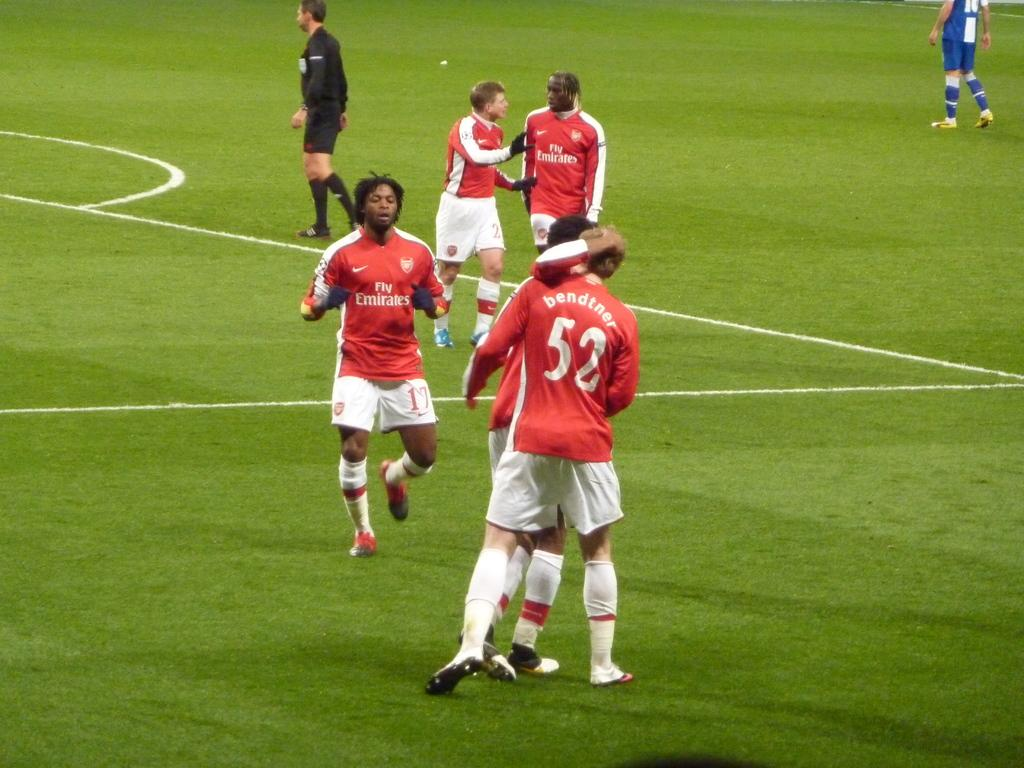Provide a one-sentence caption for the provided image. a football game, one man is wearing a number 52 shirt. 